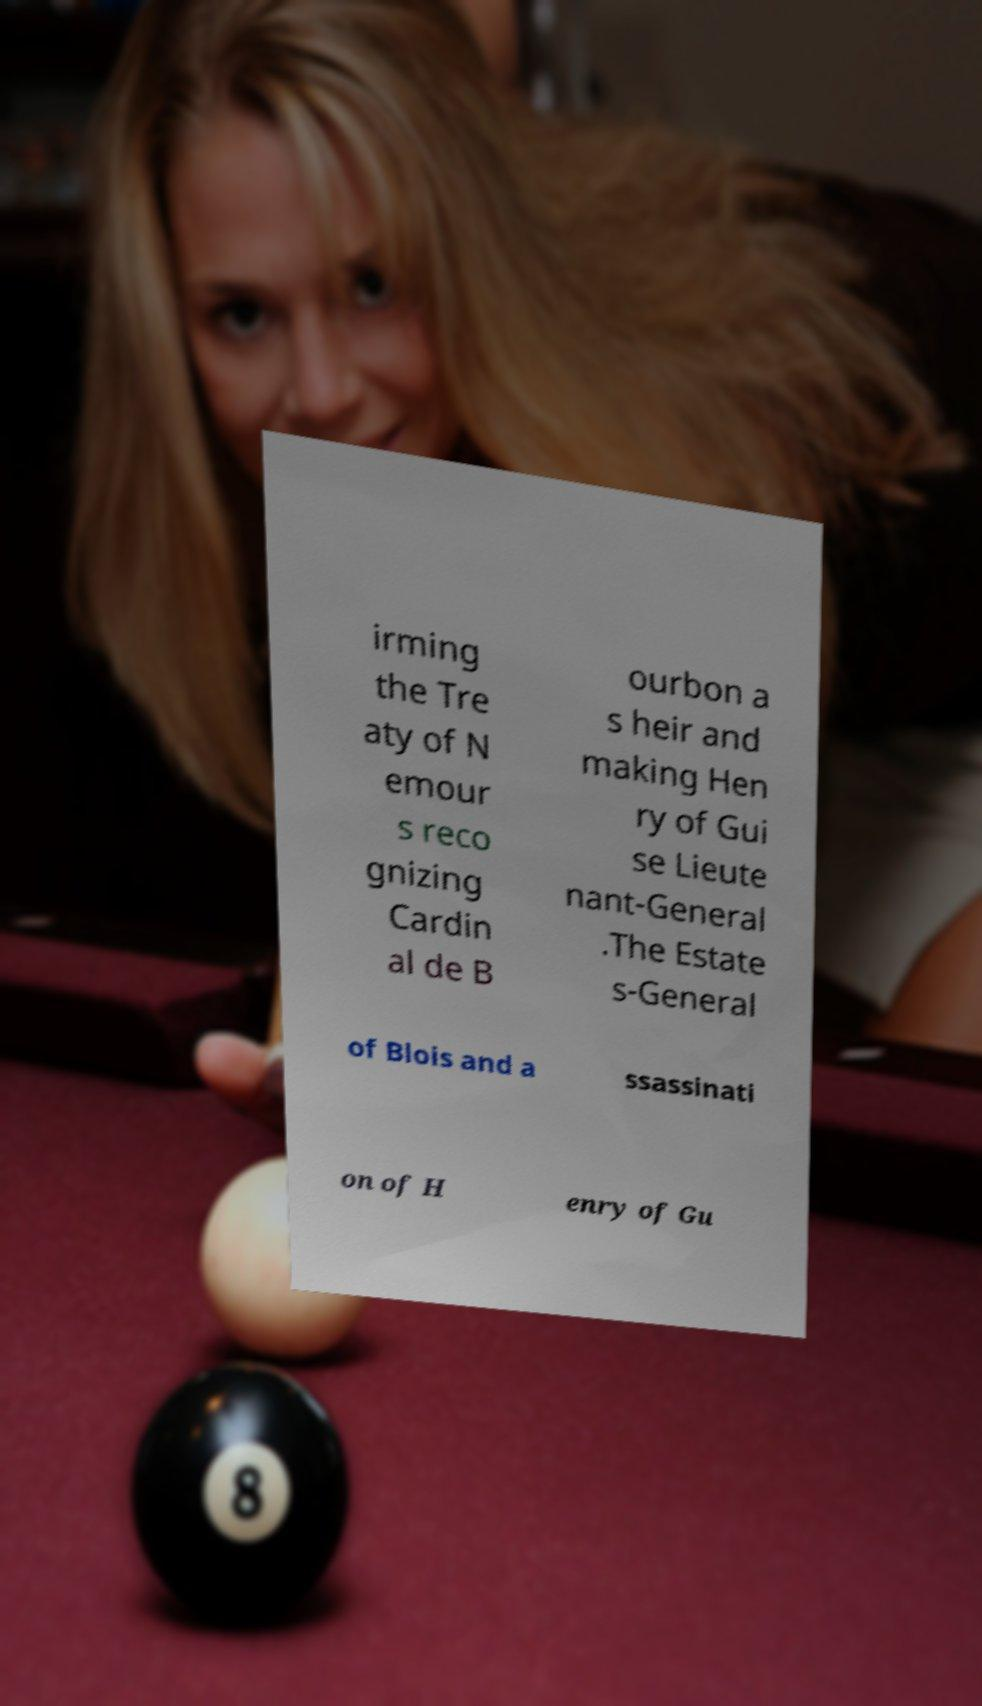I need the written content from this picture converted into text. Can you do that? irming the Tre aty of N emour s reco gnizing Cardin al de B ourbon a s heir and making Hen ry of Gui se Lieute nant-General .The Estate s-General of Blois and a ssassinati on of H enry of Gu 